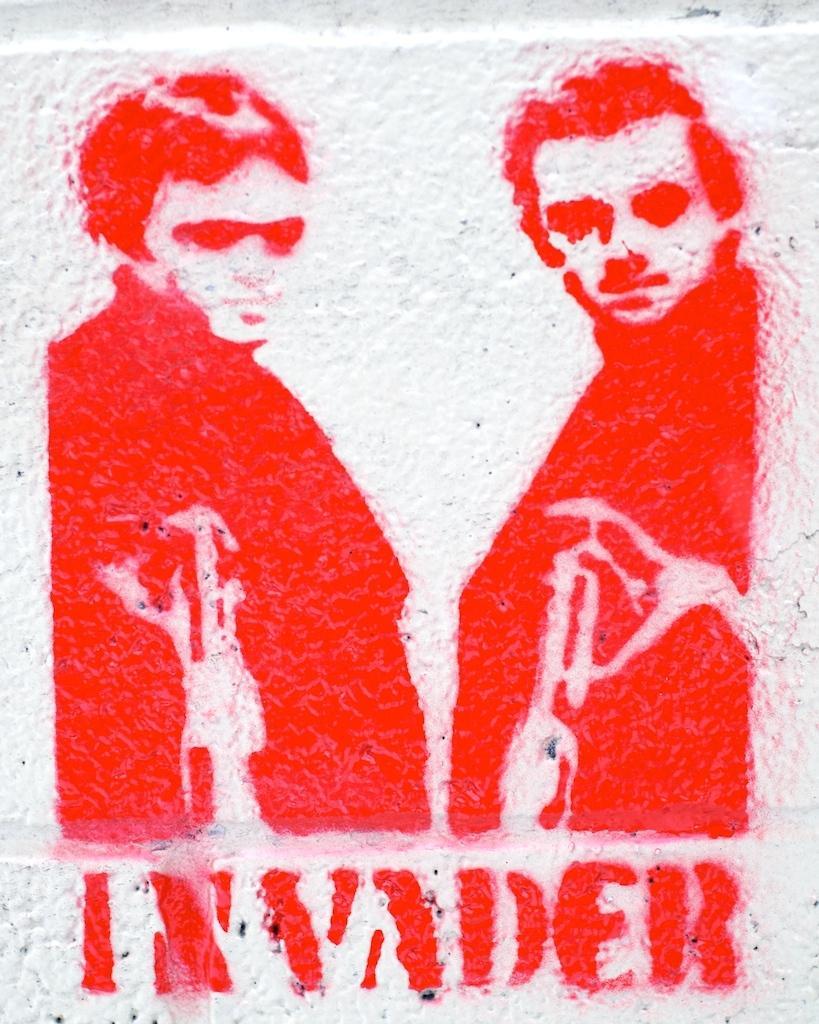Could you give a brief overview of what you see in this image? In this image, we can see an art contains depiction of persons and some text. 